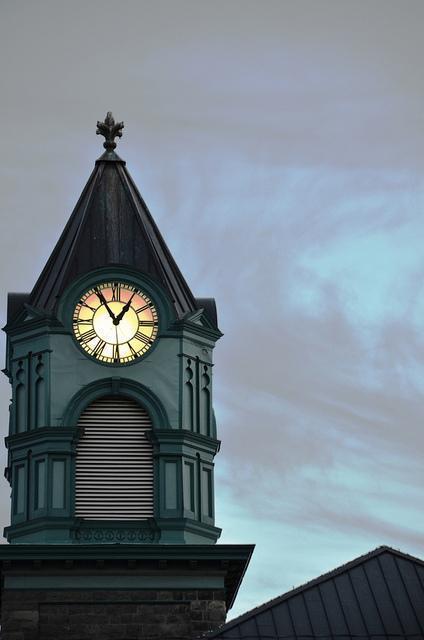How many horses are there?
Give a very brief answer. 0. 